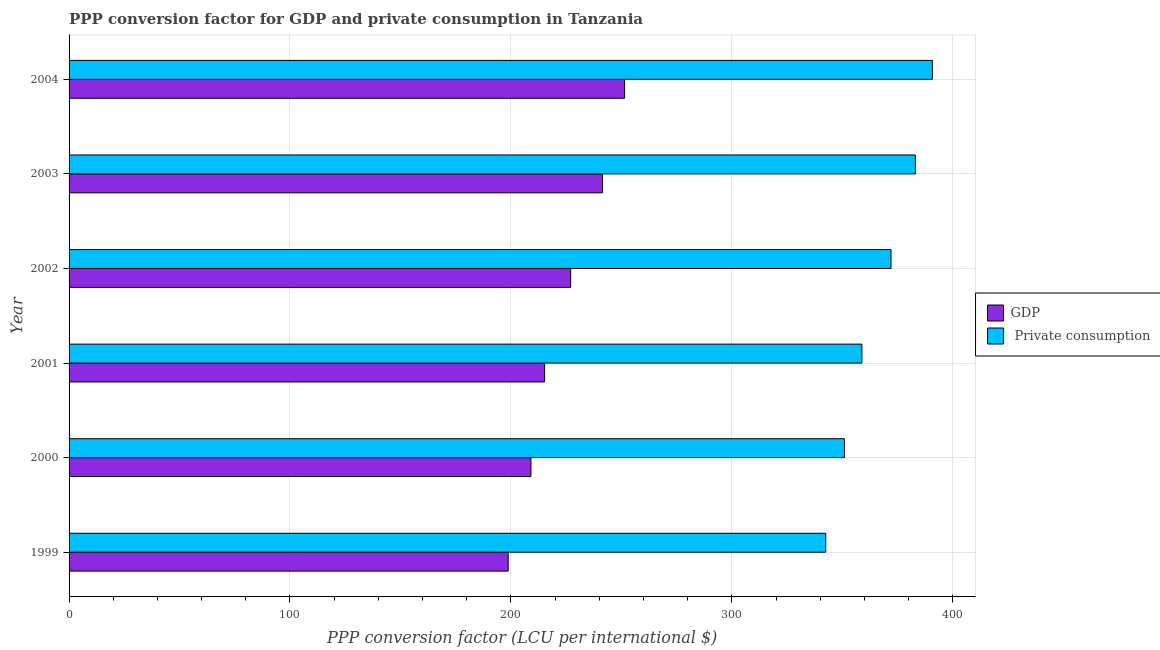How many groups of bars are there?
Offer a terse response. 6. How many bars are there on the 1st tick from the bottom?
Your answer should be compact. 2. What is the label of the 3rd group of bars from the top?
Your answer should be compact. 2002. What is the ppp conversion factor for gdp in 2000?
Give a very brief answer. 209.06. Across all years, what is the maximum ppp conversion factor for gdp?
Provide a succinct answer. 251.46. Across all years, what is the minimum ppp conversion factor for gdp?
Your answer should be compact. 198.77. In which year was the ppp conversion factor for private consumption maximum?
Offer a terse response. 2004. In which year was the ppp conversion factor for private consumption minimum?
Offer a terse response. 1999. What is the total ppp conversion factor for private consumption in the graph?
Provide a short and direct response. 2198.23. What is the difference between the ppp conversion factor for private consumption in 1999 and that in 2003?
Ensure brevity in your answer.  -40.58. What is the difference between the ppp conversion factor for gdp in 1999 and the ppp conversion factor for private consumption in 2001?
Offer a very short reply. -160.1. What is the average ppp conversion factor for gdp per year?
Make the answer very short. 223.83. In the year 2000, what is the difference between the ppp conversion factor for private consumption and ppp conversion factor for gdp?
Make the answer very short. 141.88. What is the ratio of the ppp conversion factor for gdp in 1999 to that in 2004?
Ensure brevity in your answer.  0.79. Is the ppp conversion factor for gdp in 2001 less than that in 2002?
Offer a terse response. Yes. What is the difference between the highest and the second highest ppp conversion factor for private consumption?
Offer a terse response. 7.68. What is the difference between the highest and the lowest ppp conversion factor for gdp?
Provide a succinct answer. 52.69. Is the sum of the ppp conversion factor for private consumption in 2000 and 2001 greater than the maximum ppp conversion factor for gdp across all years?
Give a very brief answer. Yes. What does the 1st bar from the top in 2003 represents?
Offer a very short reply.  Private consumption. What does the 2nd bar from the bottom in 1999 represents?
Ensure brevity in your answer.   Private consumption. How many bars are there?
Make the answer very short. 12. How many years are there in the graph?
Keep it short and to the point. 6. Does the graph contain any zero values?
Your answer should be compact. No. How are the legend labels stacked?
Offer a terse response. Vertical. What is the title of the graph?
Provide a succinct answer. PPP conversion factor for GDP and private consumption in Tanzania. Does "Investment in Transport" appear as one of the legend labels in the graph?
Keep it short and to the point. No. What is the label or title of the X-axis?
Offer a very short reply. PPP conversion factor (LCU per international $). What is the label or title of the Y-axis?
Provide a short and direct response. Year. What is the PPP conversion factor (LCU per international $) of GDP in 1999?
Your response must be concise. 198.77. What is the PPP conversion factor (LCU per international $) in  Private consumption in 1999?
Offer a very short reply. 342.51. What is the PPP conversion factor (LCU per international $) in GDP in 2000?
Give a very brief answer. 209.06. What is the PPP conversion factor (LCU per international $) of  Private consumption in 2000?
Your answer should be compact. 350.95. What is the PPP conversion factor (LCU per international $) in GDP in 2001?
Your answer should be compact. 215.25. What is the PPP conversion factor (LCU per international $) in  Private consumption in 2001?
Give a very brief answer. 358.87. What is the PPP conversion factor (LCU per international $) in GDP in 2002?
Ensure brevity in your answer.  227.05. What is the PPP conversion factor (LCU per international $) of  Private consumption in 2002?
Offer a very short reply. 372.05. What is the PPP conversion factor (LCU per international $) in GDP in 2003?
Keep it short and to the point. 241.42. What is the PPP conversion factor (LCU per international $) of  Private consumption in 2003?
Your answer should be compact. 383.09. What is the PPP conversion factor (LCU per international $) of GDP in 2004?
Your response must be concise. 251.46. What is the PPP conversion factor (LCU per international $) in  Private consumption in 2004?
Provide a succinct answer. 390.77. Across all years, what is the maximum PPP conversion factor (LCU per international $) in GDP?
Ensure brevity in your answer.  251.46. Across all years, what is the maximum PPP conversion factor (LCU per international $) in  Private consumption?
Provide a short and direct response. 390.77. Across all years, what is the minimum PPP conversion factor (LCU per international $) of GDP?
Provide a succinct answer. 198.77. Across all years, what is the minimum PPP conversion factor (LCU per international $) of  Private consumption?
Give a very brief answer. 342.51. What is the total PPP conversion factor (LCU per international $) in GDP in the graph?
Your response must be concise. 1343.01. What is the total PPP conversion factor (LCU per international $) of  Private consumption in the graph?
Offer a very short reply. 2198.23. What is the difference between the PPP conversion factor (LCU per international $) of GDP in 1999 and that in 2000?
Your answer should be compact. -10.29. What is the difference between the PPP conversion factor (LCU per international $) of  Private consumption in 1999 and that in 2000?
Your response must be concise. -8.44. What is the difference between the PPP conversion factor (LCU per international $) in GDP in 1999 and that in 2001?
Your answer should be compact. -16.48. What is the difference between the PPP conversion factor (LCU per international $) in  Private consumption in 1999 and that in 2001?
Ensure brevity in your answer.  -16.36. What is the difference between the PPP conversion factor (LCU per international $) in GDP in 1999 and that in 2002?
Give a very brief answer. -28.28. What is the difference between the PPP conversion factor (LCU per international $) in  Private consumption in 1999 and that in 2002?
Provide a short and direct response. -29.54. What is the difference between the PPP conversion factor (LCU per international $) in GDP in 1999 and that in 2003?
Ensure brevity in your answer.  -42.65. What is the difference between the PPP conversion factor (LCU per international $) in  Private consumption in 1999 and that in 2003?
Ensure brevity in your answer.  -40.58. What is the difference between the PPP conversion factor (LCU per international $) in GDP in 1999 and that in 2004?
Offer a terse response. -52.69. What is the difference between the PPP conversion factor (LCU per international $) in  Private consumption in 1999 and that in 2004?
Give a very brief answer. -48.26. What is the difference between the PPP conversion factor (LCU per international $) in GDP in 2000 and that in 2001?
Your answer should be very brief. -6.19. What is the difference between the PPP conversion factor (LCU per international $) in  Private consumption in 2000 and that in 2001?
Your answer should be very brief. -7.92. What is the difference between the PPP conversion factor (LCU per international $) of GDP in 2000 and that in 2002?
Give a very brief answer. -17.98. What is the difference between the PPP conversion factor (LCU per international $) of  Private consumption in 2000 and that in 2002?
Your answer should be compact. -21.11. What is the difference between the PPP conversion factor (LCU per international $) of GDP in 2000 and that in 2003?
Offer a very short reply. -32.35. What is the difference between the PPP conversion factor (LCU per international $) of  Private consumption in 2000 and that in 2003?
Your answer should be compact. -32.14. What is the difference between the PPP conversion factor (LCU per international $) in GDP in 2000 and that in 2004?
Your answer should be very brief. -42.39. What is the difference between the PPP conversion factor (LCU per international $) in  Private consumption in 2000 and that in 2004?
Offer a terse response. -39.82. What is the difference between the PPP conversion factor (LCU per international $) of GDP in 2001 and that in 2002?
Your answer should be very brief. -11.8. What is the difference between the PPP conversion factor (LCU per international $) of  Private consumption in 2001 and that in 2002?
Your response must be concise. -13.18. What is the difference between the PPP conversion factor (LCU per international $) in GDP in 2001 and that in 2003?
Ensure brevity in your answer.  -26.17. What is the difference between the PPP conversion factor (LCU per international $) of  Private consumption in 2001 and that in 2003?
Ensure brevity in your answer.  -24.22. What is the difference between the PPP conversion factor (LCU per international $) of GDP in 2001 and that in 2004?
Provide a short and direct response. -36.21. What is the difference between the PPP conversion factor (LCU per international $) in  Private consumption in 2001 and that in 2004?
Ensure brevity in your answer.  -31.9. What is the difference between the PPP conversion factor (LCU per international $) in GDP in 2002 and that in 2003?
Provide a short and direct response. -14.37. What is the difference between the PPP conversion factor (LCU per international $) in  Private consumption in 2002 and that in 2003?
Offer a terse response. -11.04. What is the difference between the PPP conversion factor (LCU per international $) in GDP in 2002 and that in 2004?
Your answer should be very brief. -24.41. What is the difference between the PPP conversion factor (LCU per international $) in  Private consumption in 2002 and that in 2004?
Offer a very short reply. -18.72. What is the difference between the PPP conversion factor (LCU per international $) in GDP in 2003 and that in 2004?
Ensure brevity in your answer.  -10.04. What is the difference between the PPP conversion factor (LCU per international $) in  Private consumption in 2003 and that in 2004?
Keep it short and to the point. -7.68. What is the difference between the PPP conversion factor (LCU per international $) of GDP in 1999 and the PPP conversion factor (LCU per international $) of  Private consumption in 2000?
Provide a short and direct response. -152.18. What is the difference between the PPP conversion factor (LCU per international $) in GDP in 1999 and the PPP conversion factor (LCU per international $) in  Private consumption in 2001?
Offer a very short reply. -160.1. What is the difference between the PPP conversion factor (LCU per international $) in GDP in 1999 and the PPP conversion factor (LCU per international $) in  Private consumption in 2002?
Give a very brief answer. -173.28. What is the difference between the PPP conversion factor (LCU per international $) in GDP in 1999 and the PPP conversion factor (LCU per international $) in  Private consumption in 2003?
Ensure brevity in your answer.  -184.32. What is the difference between the PPP conversion factor (LCU per international $) in GDP in 1999 and the PPP conversion factor (LCU per international $) in  Private consumption in 2004?
Give a very brief answer. -192. What is the difference between the PPP conversion factor (LCU per international $) in GDP in 2000 and the PPP conversion factor (LCU per international $) in  Private consumption in 2001?
Your answer should be very brief. -149.8. What is the difference between the PPP conversion factor (LCU per international $) of GDP in 2000 and the PPP conversion factor (LCU per international $) of  Private consumption in 2002?
Offer a very short reply. -162.99. What is the difference between the PPP conversion factor (LCU per international $) of GDP in 2000 and the PPP conversion factor (LCU per international $) of  Private consumption in 2003?
Your response must be concise. -174.02. What is the difference between the PPP conversion factor (LCU per international $) of GDP in 2000 and the PPP conversion factor (LCU per international $) of  Private consumption in 2004?
Offer a terse response. -181.7. What is the difference between the PPP conversion factor (LCU per international $) of GDP in 2001 and the PPP conversion factor (LCU per international $) of  Private consumption in 2002?
Keep it short and to the point. -156.8. What is the difference between the PPP conversion factor (LCU per international $) in GDP in 2001 and the PPP conversion factor (LCU per international $) in  Private consumption in 2003?
Ensure brevity in your answer.  -167.84. What is the difference between the PPP conversion factor (LCU per international $) of GDP in 2001 and the PPP conversion factor (LCU per international $) of  Private consumption in 2004?
Give a very brief answer. -175.52. What is the difference between the PPP conversion factor (LCU per international $) of GDP in 2002 and the PPP conversion factor (LCU per international $) of  Private consumption in 2003?
Provide a short and direct response. -156.04. What is the difference between the PPP conversion factor (LCU per international $) in GDP in 2002 and the PPP conversion factor (LCU per international $) in  Private consumption in 2004?
Offer a very short reply. -163.72. What is the difference between the PPP conversion factor (LCU per international $) in GDP in 2003 and the PPP conversion factor (LCU per international $) in  Private consumption in 2004?
Keep it short and to the point. -149.35. What is the average PPP conversion factor (LCU per international $) in GDP per year?
Give a very brief answer. 223.83. What is the average PPP conversion factor (LCU per international $) of  Private consumption per year?
Make the answer very short. 366.37. In the year 1999, what is the difference between the PPP conversion factor (LCU per international $) in GDP and PPP conversion factor (LCU per international $) in  Private consumption?
Keep it short and to the point. -143.74. In the year 2000, what is the difference between the PPP conversion factor (LCU per international $) in GDP and PPP conversion factor (LCU per international $) in  Private consumption?
Provide a short and direct response. -141.88. In the year 2001, what is the difference between the PPP conversion factor (LCU per international $) in GDP and PPP conversion factor (LCU per international $) in  Private consumption?
Your response must be concise. -143.62. In the year 2002, what is the difference between the PPP conversion factor (LCU per international $) in GDP and PPP conversion factor (LCU per international $) in  Private consumption?
Your answer should be very brief. -145.01. In the year 2003, what is the difference between the PPP conversion factor (LCU per international $) in GDP and PPP conversion factor (LCU per international $) in  Private consumption?
Keep it short and to the point. -141.67. In the year 2004, what is the difference between the PPP conversion factor (LCU per international $) in GDP and PPP conversion factor (LCU per international $) in  Private consumption?
Keep it short and to the point. -139.31. What is the ratio of the PPP conversion factor (LCU per international $) of GDP in 1999 to that in 2000?
Provide a short and direct response. 0.95. What is the ratio of the PPP conversion factor (LCU per international $) of  Private consumption in 1999 to that in 2000?
Give a very brief answer. 0.98. What is the ratio of the PPP conversion factor (LCU per international $) in GDP in 1999 to that in 2001?
Your answer should be compact. 0.92. What is the ratio of the PPP conversion factor (LCU per international $) in  Private consumption in 1999 to that in 2001?
Your answer should be very brief. 0.95. What is the ratio of the PPP conversion factor (LCU per international $) of GDP in 1999 to that in 2002?
Provide a short and direct response. 0.88. What is the ratio of the PPP conversion factor (LCU per international $) of  Private consumption in 1999 to that in 2002?
Your response must be concise. 0.92. What is the ratio of the PPP conversion factor (LCU per international $) in GDP in 1999 to that in 2003?
Ensure brevity in your answer.  0.82. What is the ratio of the PPP conversion factor (LCU per international $) in  Private consumption in 1999 to that in 2003?
Give a very brief answer. 0.89. What is the ratio of the PPP conversion factor (LCU per international $) of GDP in 1999 to that in 2004?
Keep it short and to the point. 0.79. What is the ratio of the PPP conversion factor (LCU per international $) in  Private consumption in 1999 to that in 2004?
Your answer should be very brief. 0.88. What is the ratio of the PPP conversion factor (LCU per international $) in GDP in 2000 to that in 2001?
Your answer should be very brief. 0.97. What is the ratio of the PPP conversion factor (LCU per international $) of  Private consumption in 2000 to that in 2001?
Provide a short and direct response. 0.98. What is the ratio of the PPP conversion factor (LCU per international $) of GDP in 2000 to that in 2002?
Offer a very short reply. 0.92. What is the ratio of the PPP conversion factor (LCU per international $) in  Private consumption in 2000 to that in 2002?
Keep it short and to the point. 0.94. What is the ratio of the PPP conversion factor (LCU per international $) in GDP in 2000 to that in 2003?
Provide a short and direct response. 0.87. What is the ratio of the PPP conversion factor (LCU per international $) of  Private consumption in 2000 to that in 2003?
Your response must be concise. 0.92. What is the ratio of the PPP conversion factor (LCU per international $) of GDP in 2000 to that in 2004?
Your response must be concise. 0.83. What is the ratio of the PPP conversion factor (LCU per international $) of  Private consumption in 2000 to that in 2004?
Provide a succinct answer. 0.9. What is the ratio of the PPP conversion factor (LCU per international $) of GDP in 2001 to that in 2002?
Your answer should be compact. 0.95. What is the ratio of the PPP conversion factor (LCU per international $) of  Private consumption in 2001 to that in 2002?
Provide a succinct answer. 0.96. What is the ratio of the PPP conversion factor (LCU per international $) in GDP in 2001 to that in 2003?
Offer a very short reply. 0.89. What is the ratio of the PPP conversion factor (LCU per international $) in  Private consumption in 2001 to that in 2003?
Offer a very short reply. 0.94. What is the ratio of the PPP conversion factor (LCU per international $) in GDP in 2001 to that in 2004?
Make the answer very short. 0.86. What is the ratio of the PPP conversion factor (LCU per international $) in  Private consumption in 2001 to that in 2004?
Give a very brief answer. 0.92. What is the ratio of the PPP conversion factor (LCU per international $) of GDP in 2002 to that in 2003?
Your answer should be very brief. 0.94. What is the ratio of the PPP conversion factor (LCU per international $) in  Private consumption in 2002 to that in 2003?
Keep it short and to the point. 0.97. What is the ratio of the PPP conversion factor (LCU per international $) in GDP in 2002 to that in 2004?
Offer a very short reply. 0.9. What is the ratio of the PPP conversion factor (LCU per international $) in  Private consumption in 2002 to that in 2004?
Your answer should be compact. 0.95. What is the ratio of the PPP conversion factor (LCU per international $) of GDP in 2003 to that in 2004?
Give a very brief answer. 0.96. What is the ratio of the PPP conversion factor (LCU per international $) of  Private consumption in 2003 to that in 2004?
Offer a terse response. 0.98. What is the difference between the highest and the second highest PPP conversion factor (LCU per international $) in GDP?
Make the answer very short. 10.04. What is the difference between the highest and the second highest PPP conversion factor (LCU per international $) in  Private consumption?
Ensure brevity in your answer.  7.68. What is the difference between the highest and the lowest PPP conversion factor (LCU per international $) in GDP?
Your answer should be very brief. 52.69. What is the difference between the highest and the lowest PPP conversion factor (LCU per international $) in  Private consumption?
Your answer should be compact. 48.26. 